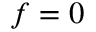<formula> <loc_0><loc_0><loc_500><loc_500>f = 0</formula> 